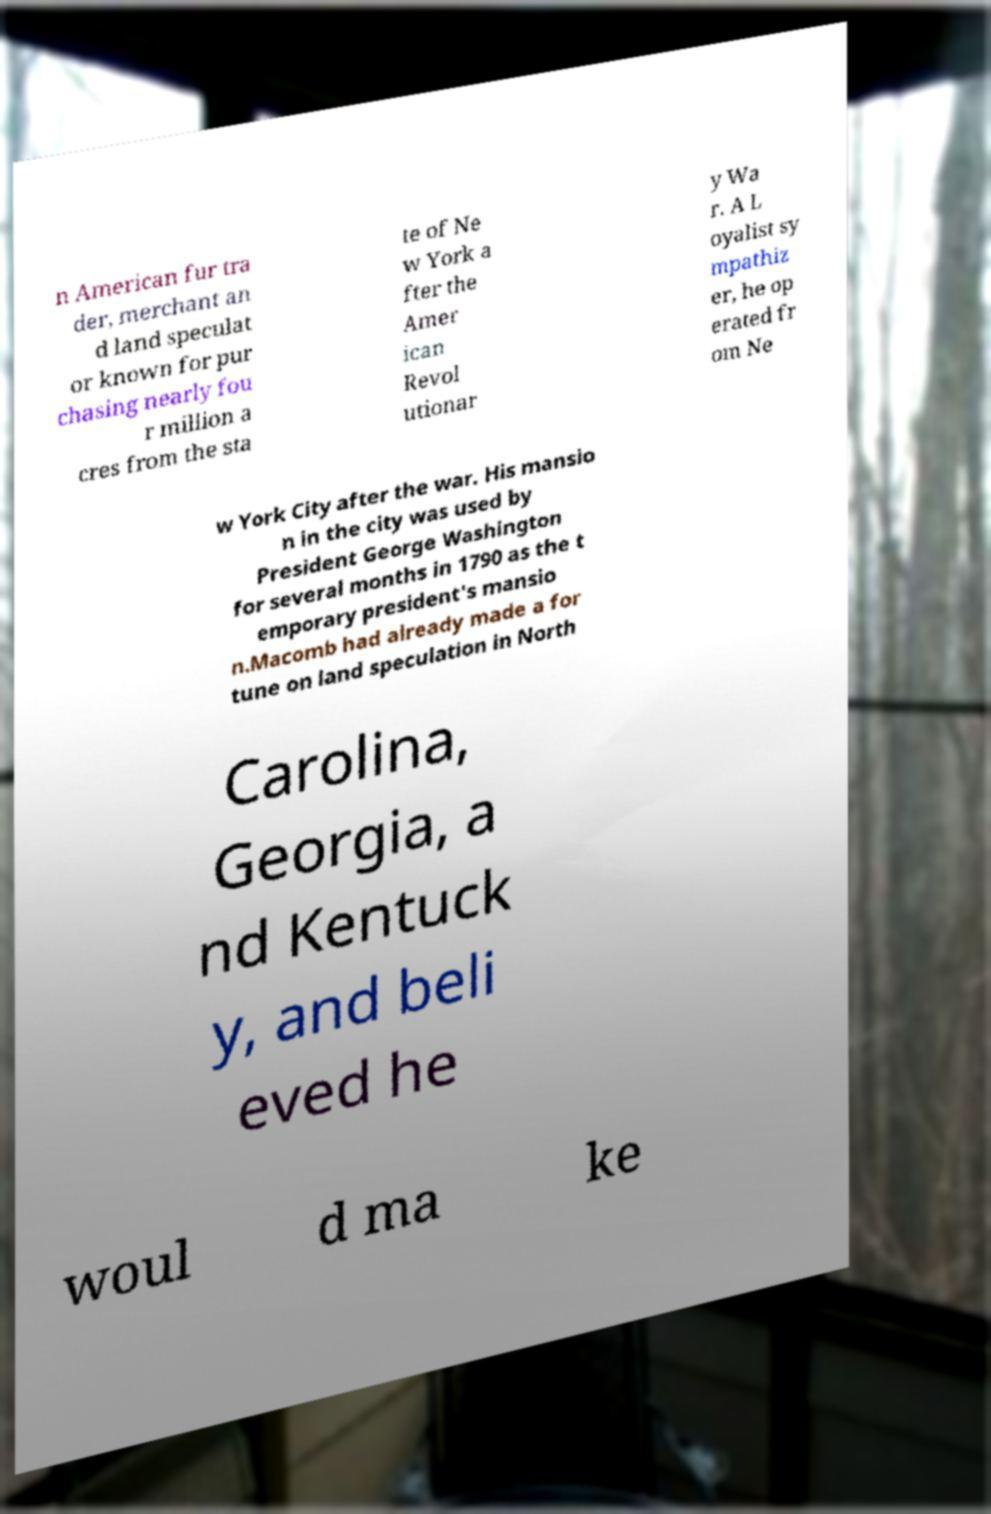Please identify and transcribe the text found in this image. n American fur tra der, merchant an d land speculat or known for pur chasing nearly fou r million a cres from the sta te of Ne w York a fter the Amer ican Revol utionar y Wa r. A L oyalist sy mpathiz er, he op erated fr om Ne w York City after the war. His mansio n in the city was used by President George Washington for several months in 1790 as the t emporary president's mansio n.Macomb had already made a for tune on land speculation in North Carolina, Georgia, a nd Kentuck y, and beli eved he woul d ma ke 